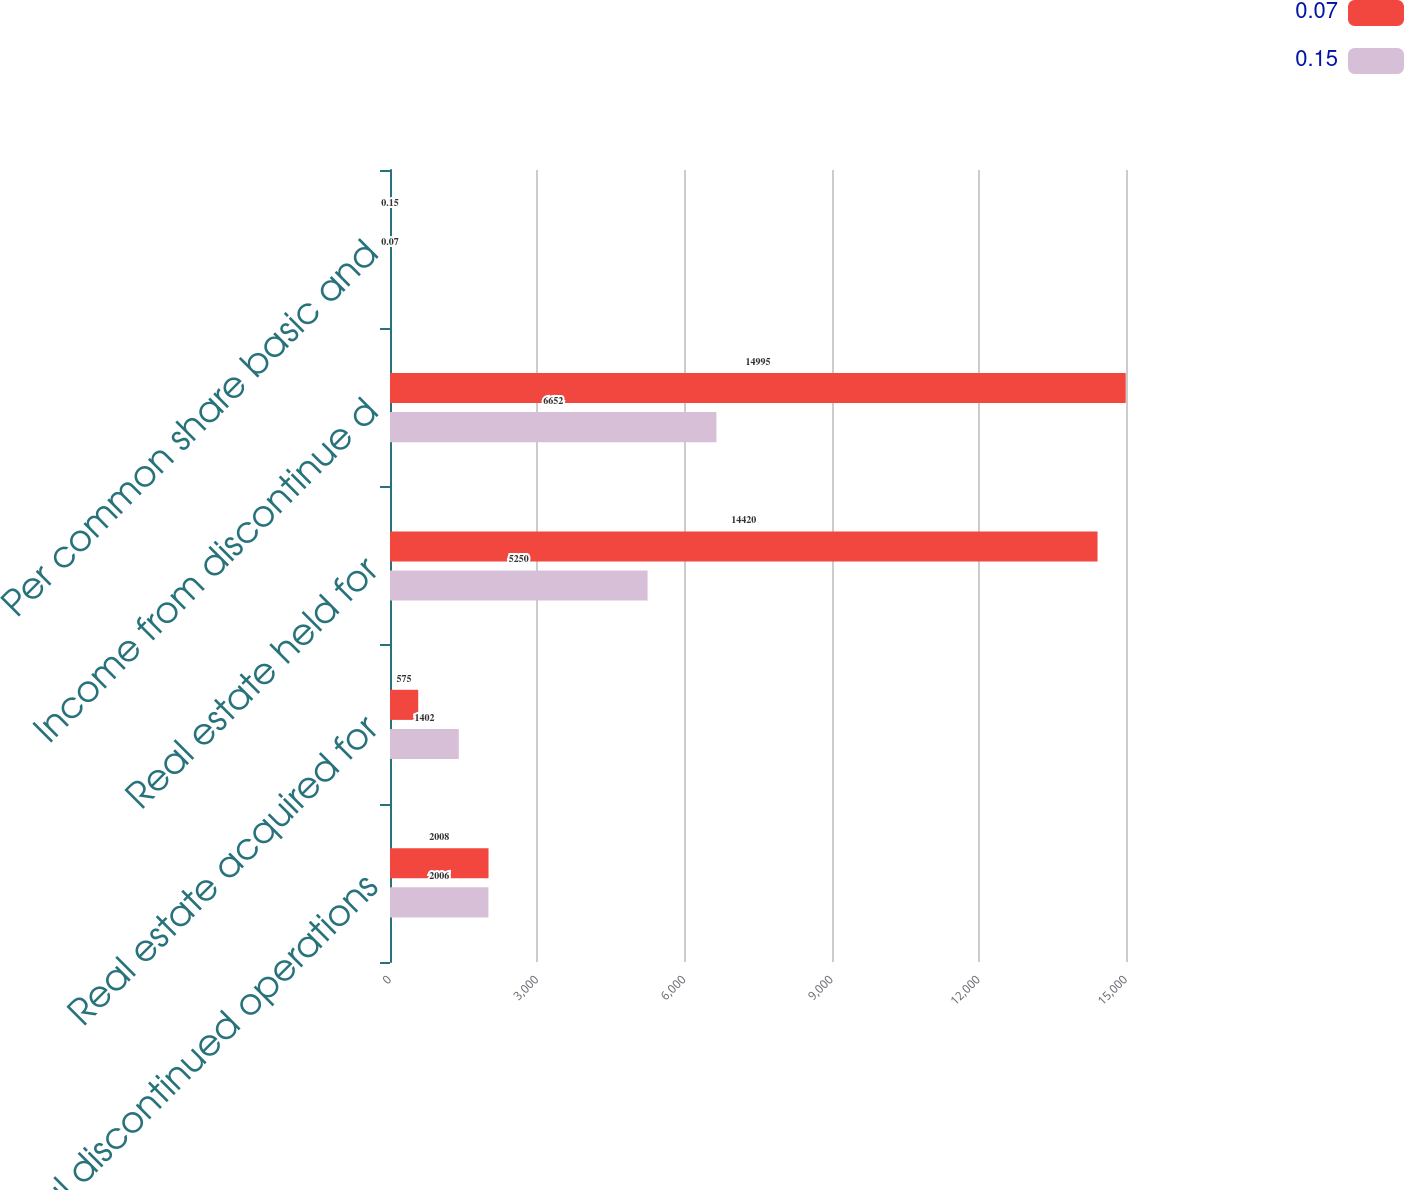Convert chart. <chart><loc_0><loc_0><loc_500><loc_500><stacked_bar_chart><ecel><fcel>Total discontinued operations<fcel>Real estate acquired for<fcel>Real estate held for<fcel>Income from discontinue d<fcel>Per common share basic and<nl><fcel>0.07<fcel>2008<fcel>575<fcel>14420<fcel>14995<fcel>0.15<nl><fcel>0.15<fcel>2006<fcel>1402<fcel>5250<fcel>6652<fcel>0.07<nl></chart> 